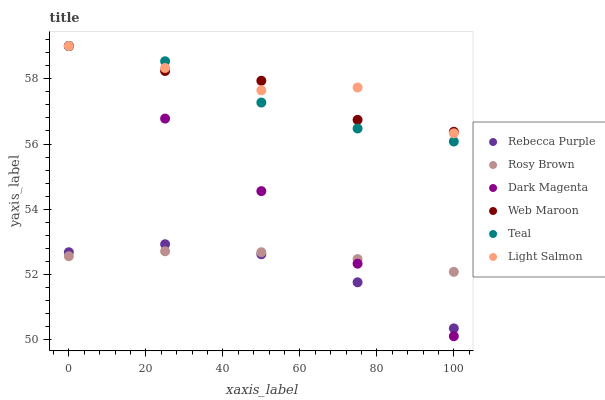Does Rebecca Purple have the minimum area under the curve?
Answer yes or no. Yes. Does Light Salmon have the maximum area under the curve?
Answer yes or no. Yes. Does Dark Magenta have the minimum area under the curve?
Answer yes or no. No. Does Dark Magenta have the maximum area under the curve?
Answer yes or no. No. Is Dark Magenta the smoothest?
Answer yes or no. Yes. Is Light Salmon the roughest?
Answer yes or no. Yes. Is Rosy Brown the smoothest?
Answer yes or no. No. Is Rosy Brown the roughest?
Answer yes or no. No. Does Dark Magenta have the lowest value?
Answer yes or no. Yes. Does Rosy Brown have the lowest value?
Answer yes or no. No. Does Teal have the highest value?
Answer yes or no. Yes. Does Rosy Brown have the highest value?
Answer yes or no. No. Is Rebecca Purple less than Light Salmon?
Answer yes or no. Yes. Is Light Salmon greater than Rebecca Purple?
Answer yes or no. Yes. Does Dark Magenta intersect Rosy Brown?
Answer yes or no. Yes. Is Dark Magenta less than Rosy Brown?
Answer yes or no. No. Is Dark Magenta greater than Rosy Brown?
Answer yes or no. No. Does Rebecca Purple intersect Light Salmon?
Answer yes or no. No. 